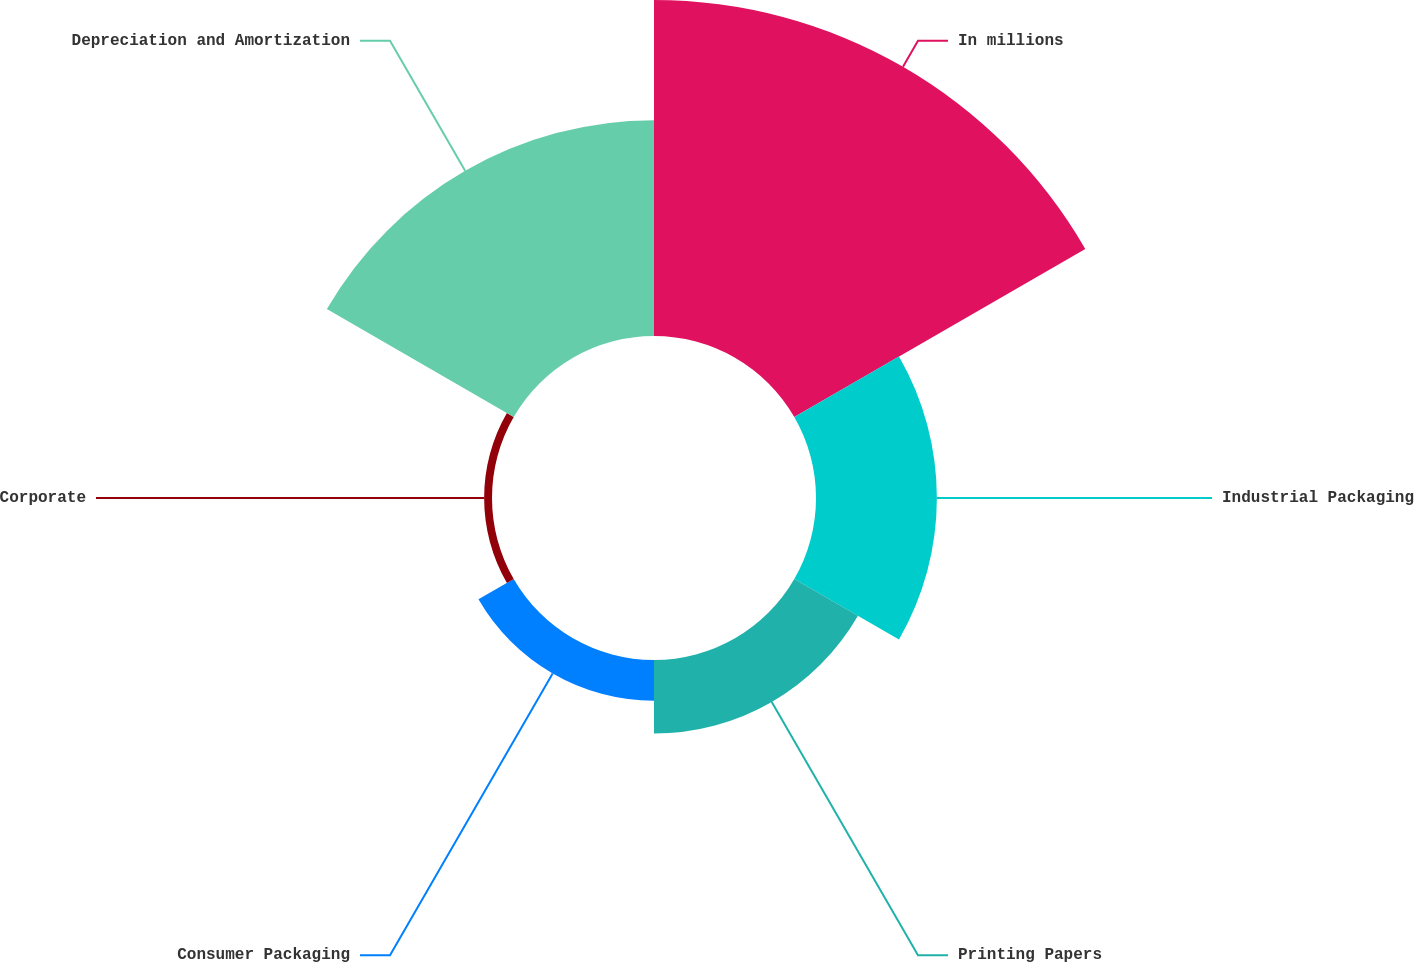<chart> <loc_0><loc_0><loc_500><loc_500><pie_chart><fcel>In millions<fcel>Industrial Packaging<fcel>Printing Papers<fcel>Consumer Packaging<fcel>Corporate<fcel>Depreciation and Amortization<nl><fcel>42.28%<fcel>15.21%<fcel>9.25%<fcel>5.12%<fcel>0.99%<fcel>27.15%<nl></chart> 